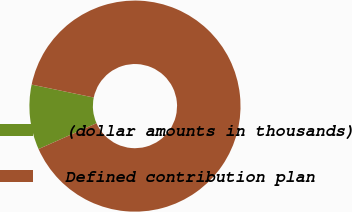Convert chart to OTSL. <chart><loc_0><loc_0><loc_500><loc_500><pie_chart><fcel>(dollar amounts in thousands)<fcel>Defined contribution plan<nl><fcel>9.94%<fcel>90.06%<nl></chart> 